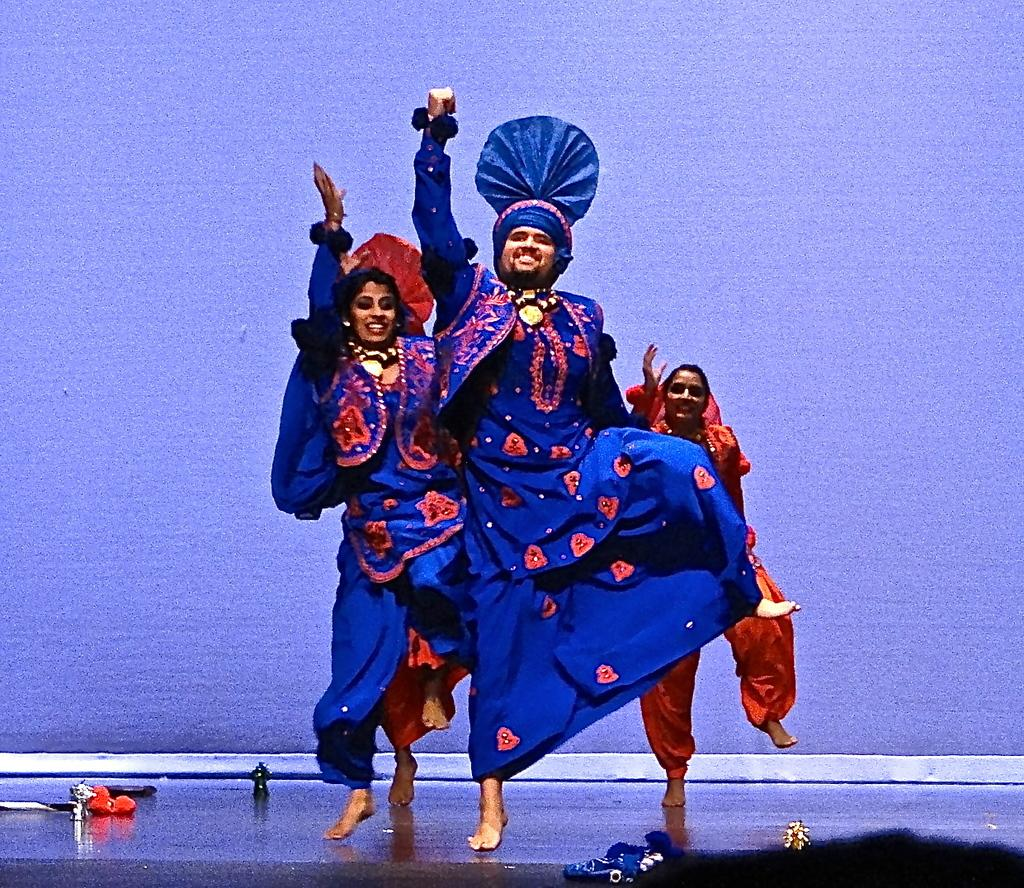How many people are in the image? There are four persons in the image. What are the persons doing in the image? The persons are dancing on a stage. What are the persons wearing while dancing? The persons are wearing costumes. What color is the background of the image? The background of the image is purple. Can you see any airplanes or icicles in the image? No, there are no airplanes or icicles present in the image. Are there any girls dancing on the stage in the image? The provided facts do not mention the gender of the dancers, so we cannot determine if there are any girls dancing on the stage. 